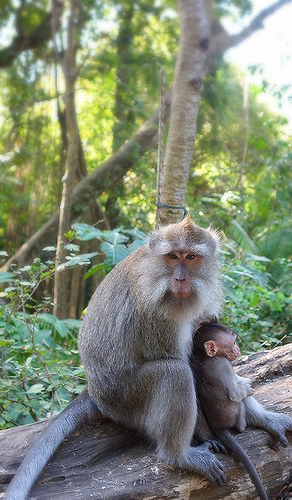<image>
Is there a monkey on the plant? No. The monkey is not positioned on the plant. They may be near each other, but the monkey is not supported by or resting on top of the plant. 